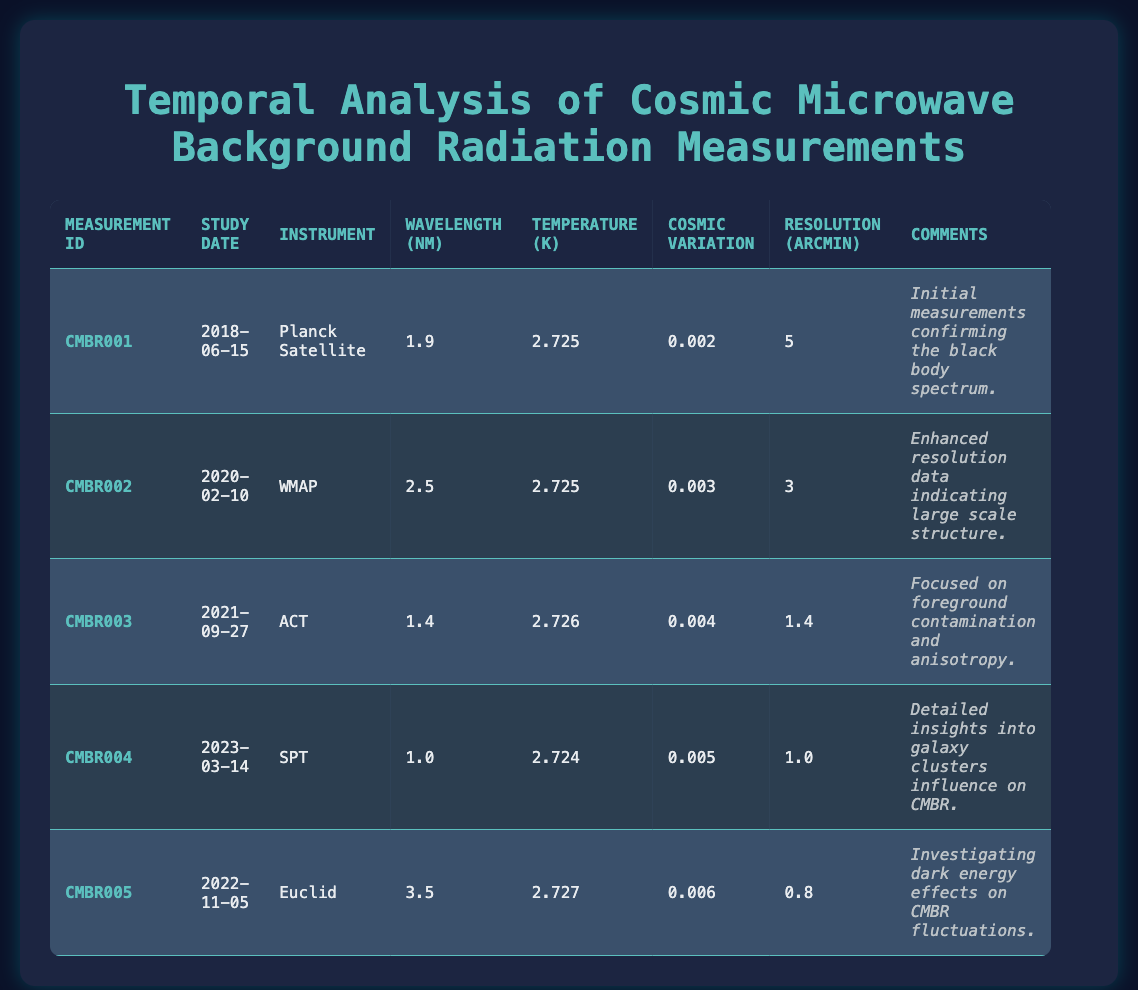What is the temperature measured by the Planck Satellite? The table indicates that the temperature measured with the Planck Satellite (measurement ID CMBR001) is 2.725 K.
Answer: 2.725 K Which instrument had the highest resolution in the measurements? By analyzing the resolution column, the instrument with the highest resolution (smallest value) is Euclid (0.8 arcmin).
Answer: Euclid What is the cosmic variation of the measurements taken by the ACT? According to the table, the cosmic variation for the ACT measurements (CMBR003) is 0.004.
Answer: 0.004 How many measurements recorded temperatures greater than 2.725 K? Reviewing the temperature values, two measurements (CMBR003 with 2.726 K and CMBR005 with 2.727 K) recorded temperatures greater than 2.725 K, bringing the total to 2.
Answer: 2 What is the average wavelength of all measurements listed in the table? The wavelengths are 1.9, 2.5, 1.4, 1.0, and 3.5 nm. The sum of these values is 10.3 nm, and there are 5 measurements: 10.3/5 = 2.06 nm.
Answer: 2.06 nm Did any of the measurements have a cosmic variation less than 0.005? Comparing the cosmic variation values, CMBR001 (0.002), CMBR002 (0.003), and CMBR003 (0.004) all have values less than 0.005, confirming that there are measurements that meet this criterion.
Answer: Yes What was the instrument used for the measurement taken on 2022-11-05? The study date 2022-11-05 corresponds to the measurement ID CMBR005, which utilized the Euclid instrument.
Answer: Euclid Which measurement had the most recent date, and what was its cosmic variation? The most recent date in the table is 2023-03-14, which corresponds to CMBR004 with a cosmic variation of 0.005.
Answer: CMBR004, 0.005 What can be inferred about the trend in cosmic variation over the years based on these measurements? Reviewing the cosmic variations over the measuring years, the values gradually increase from 0.002 in 2018 to 0.006 in 2022, indicating a trend of increasing cosmic variation in the data collected.
Answer: Increasing trend 